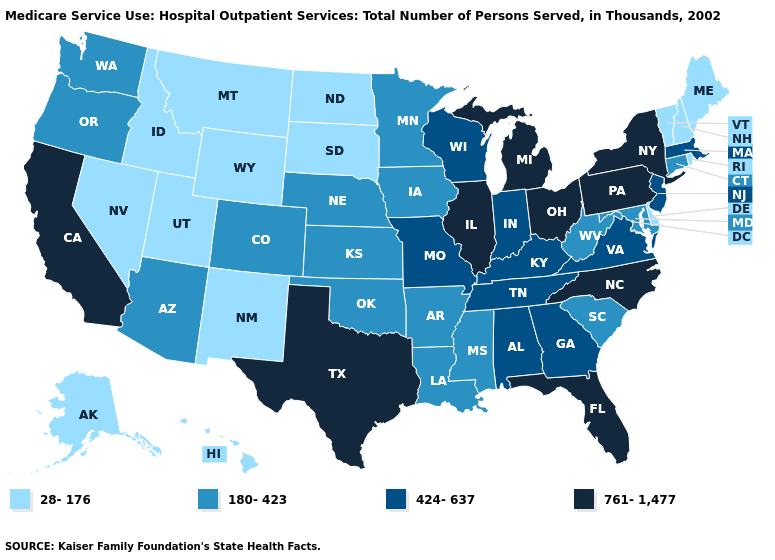Among the states that border South Carolina , which have the lowest value?
Write a very short answer. Georgia. What is the highest value in the USA?
Answer briefly. 761-1,477. What is the value of North Carolina?
Answer briefly. 761-1,477. What is the highest value in states that border Tennessee?
Short answer required. 761-1,477. Among the states that border Mississippi , which have the highest value?
Write a very short answer. Alabama, Tennessee. What is the value of North Carolina?
Short answer required. 761-1,477. What is the value of Hawaii?
Short answer required. 28-176. What is the value of Vermont?
Be succinct. 28-176. Among the states that border West Virginia , does Maryland have the lowest value?
Concise answer only. Yes. Name the states that have a value in the range 28-176?
Write a very short answer. Alaska, Delaware, Hawaii, Idaho, Maine, Montana, Nevada, New Hampshire, New Mexico, North Dakota, Rhode Island, South Dakota, Utah, Vermont, Wyoming. Which states have the lowest value in the USA?
Write a very short answer. Alaska, Delaware, Hawaii, Idaho, Maine, Montana, Nevada, New Hampshire, New Mexico, North Dakota, Rhode Island, South Dakota, Utah, Vermont, Wyoming. Among the states that border Georgia , does Alabama have the lowest value?
Concise answer only. No. What is the value of Virginia?
Short answer required. 424-637. Does the map have missing data?
Short answer required. No. Name the states that have a value in the range 180-423?
Keep it brief. Arizona, Arkansas, Colorado, Connecticut, Iowa, Kansas, Louisiana, Maryland, Minnesota, Mississippi, Nebraska, Oklahoma, Oregon, South Carolina, Washington, West Virginia. 